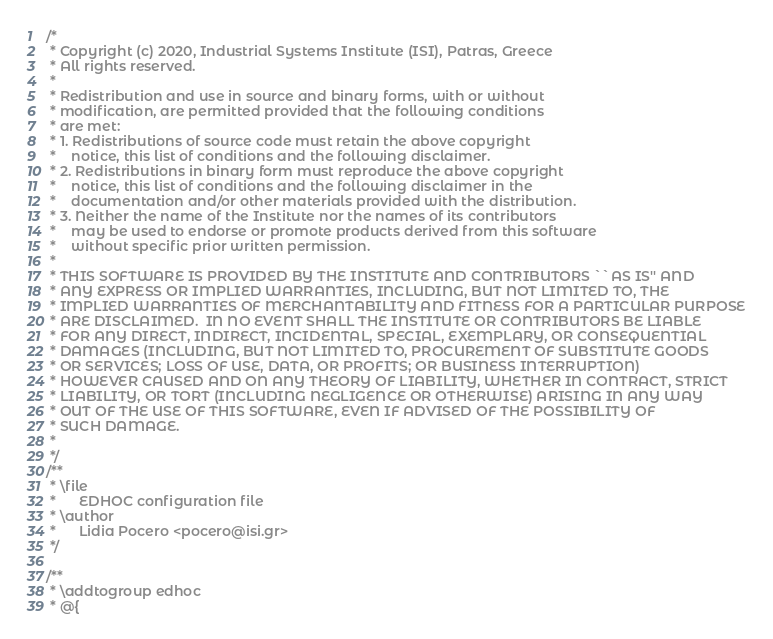<code> <loc_0><loc_0><loc_500><loc_500><_C_>/*
 * Copyright (c) 2020, Industrial Systems Institute (ISI), Patras, Greece
 * All rights reserved.
 *
 * Redistribution and use in source and binary forms, with or without
 * modification, are permitted provided that the following conditions
 * are met:
 * 1. Redistributions of source code must retain the above copyright
 *    notice, this list of conditions and the following disclaimer.
 * 2. Redistributions in binary form must reproduce the above copyright
 *    notice, this list of conditions and the following disclaimer in the
 *    documentation and/or other materials provided with the distribution.
 * 3. Neither the name of the Institute nor the names of its contributors
 *    may be used to endorse or promote products derived from this software
 *    without specific prior written permission.
 *
 * THIS SOFTWARE IS PROVIDED BY THE INSTITUTE AND CONTRIBUTORS ``AS IS'' AND
 * ANY EXPRESS OR IMPLIED WARRANTIES, INCLUDING, BUT NOT LIMITED TO, THE
 * IMPLIED WARRANTIES OF MERCHANTABILITY AND FITNESS FOR A PARTICULAR PURPOSE
 * ARE DISCLAIMED.  IN NO EVENT SHALL THE INSTITUTE OR CONTRIBUTORS BE LIABLE
 * FOR ANY DIRECT, INDIRECT, INCIDENTAL, SPECIAL, EXEMPLARY, OR CONSEQUENTIAL
 * DAMAGES (INCLUDING, BUT NOT LIMITED TO, PROCUREMENT OF SUBSTITUTE GOODS
 * OR SERVICES; LOSS OF USE, DATA, OR PROFITS; OR BUSINESS INTERRUPTION)
 * HOWEVER CAUSED AND ON ANY THEORY OF LIABILITY, WHETHER IN CONTRACT, STRICT
 * LIABILITY, OR TORT (INCLUDING NEGLIGENCE OR OTHERWISE) ARISING IN ANY WAY
 * OUT OF THE USE OF THIS SOFTWARE, EVEN IF ADVISED OF THE POSSIBILITY OF
 * SUCH DAMAGE.
 *
 */
/**
 * \file
 *      EDHOC configuration file
 * \author
 *      Lidia Pocero <pocero@isi.gr>
 */

/**
 * \addtogroup edhoc
 * @{</code> 